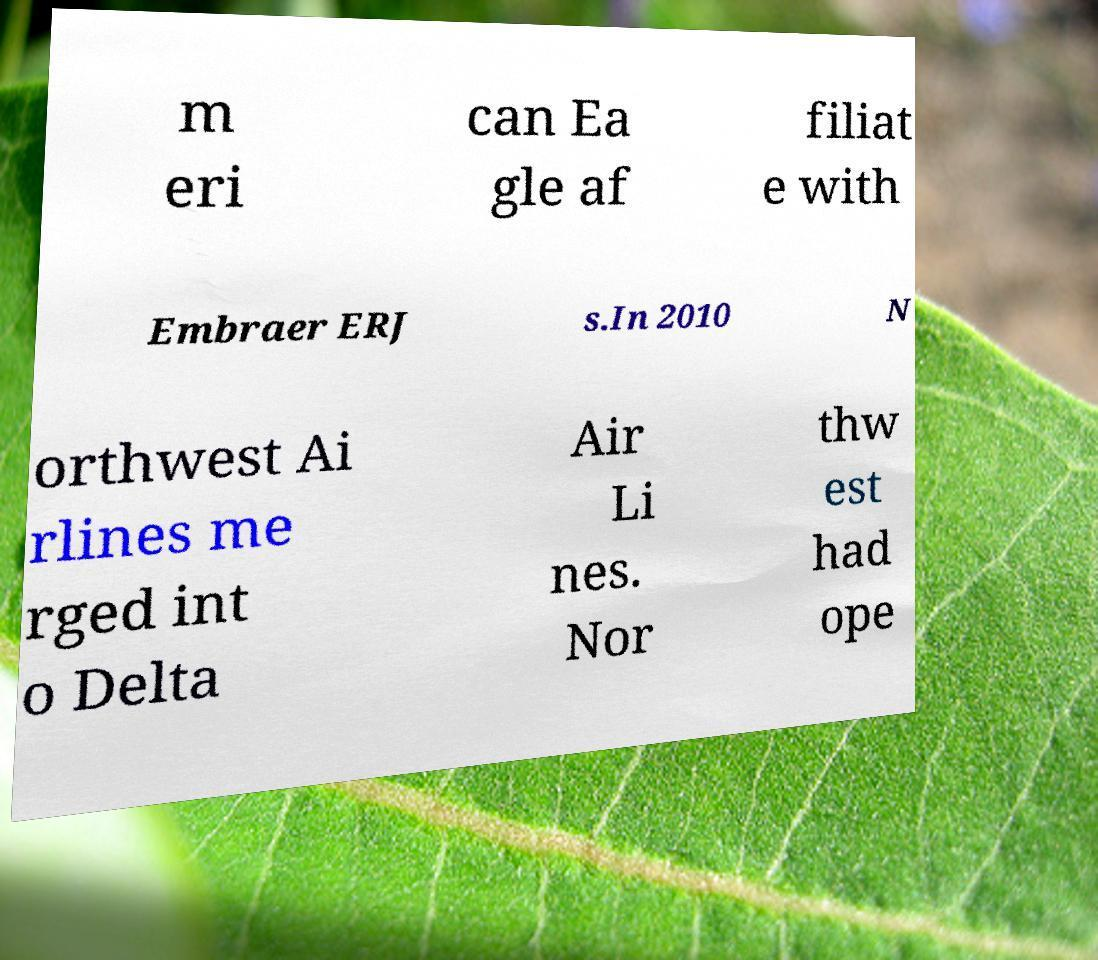Please identify and transcribe the text found in this image. m eri can Ea gle af filiat e with Embraer ERJ s.In 2010 N orthwest Ai rlines me rged int o Delta Air Li nes. Nor thw est had ope 